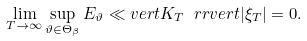Convert formula to latex. <formula><loc_0><loc_0><loc_500><loc_500>\lim _ { T \to \infty } \sup _ { \vartheta \in \Theta _ { \beta } } E _ { \vartheta } \ll v e r t K _ { T } \ r r v e r t | \xi _ { T } | = 0 .</formula> 